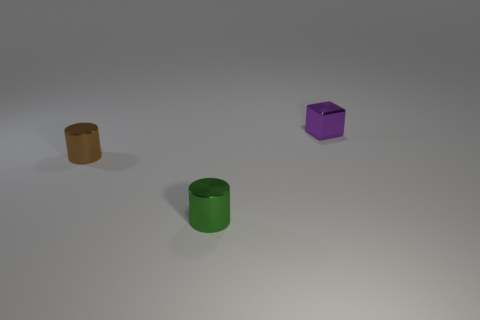How many shiny things are either brown objects or big cyan cubes?
Your answer should be compact. 1. The other shiny thing that is the same shape as the green object is what color?
Your answer should be compact. Brown. How many things are yellow cubes or brown shiny cylinders?
Ensure brevity in your answer.  1. What is the shape of the brown thing that is the same material as the green object?
Ensure brevity in your answer.  Cylinder. What number of tiny objects are green cylinders or rubber balls?
Ensure brevity in your answer.  1. There is a metallic thing to the right of the metallic cylinder that is in front of the brown shiny cylinder; how many metal things are behind it?
Make the answer very short. 0. There is a thing in front of the brown cylinder; is its size the same as the tiny brown thing?
Provide a short and direct response. Yes. Are there fewer blocks behind the tiny purple metal block than metal blocks in front of the green shiny object?
Your answer should be very brief. No. Are there fewer small purple metallic cubes to the left of the green object than purple cubes?
Provide a succinct answer. Yes. Do the purple cube and the tiny brown object have the same material?
Provide a short and direct response. Yes. 